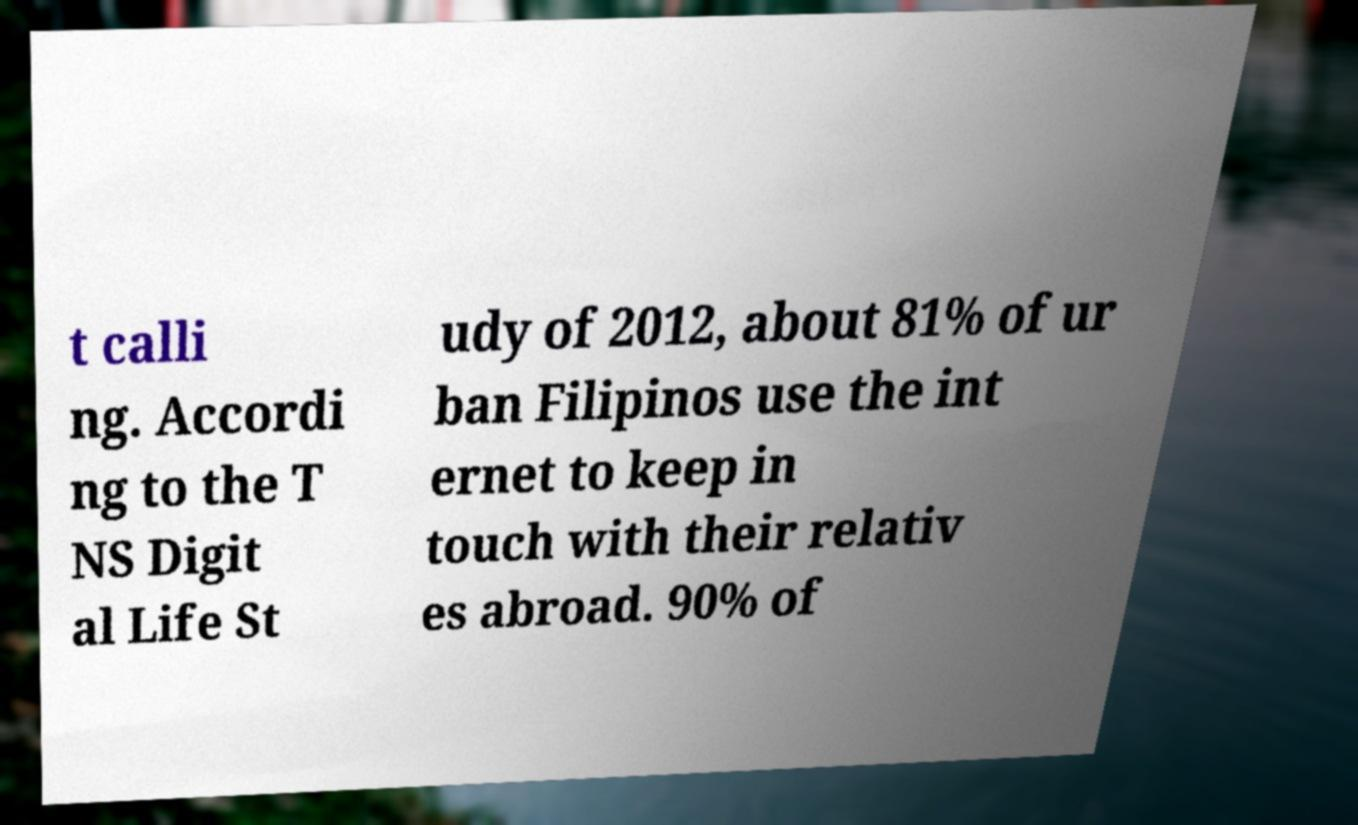What messages or text are displayed in this image? I need them in a readable, typed format. t calli ng. Accordi ng to the T NS Digit al Life St udy of 2012, about 81% of ur ban Filipinos use the int ernet to keep in touch with their relativ es abroad. 90% of 